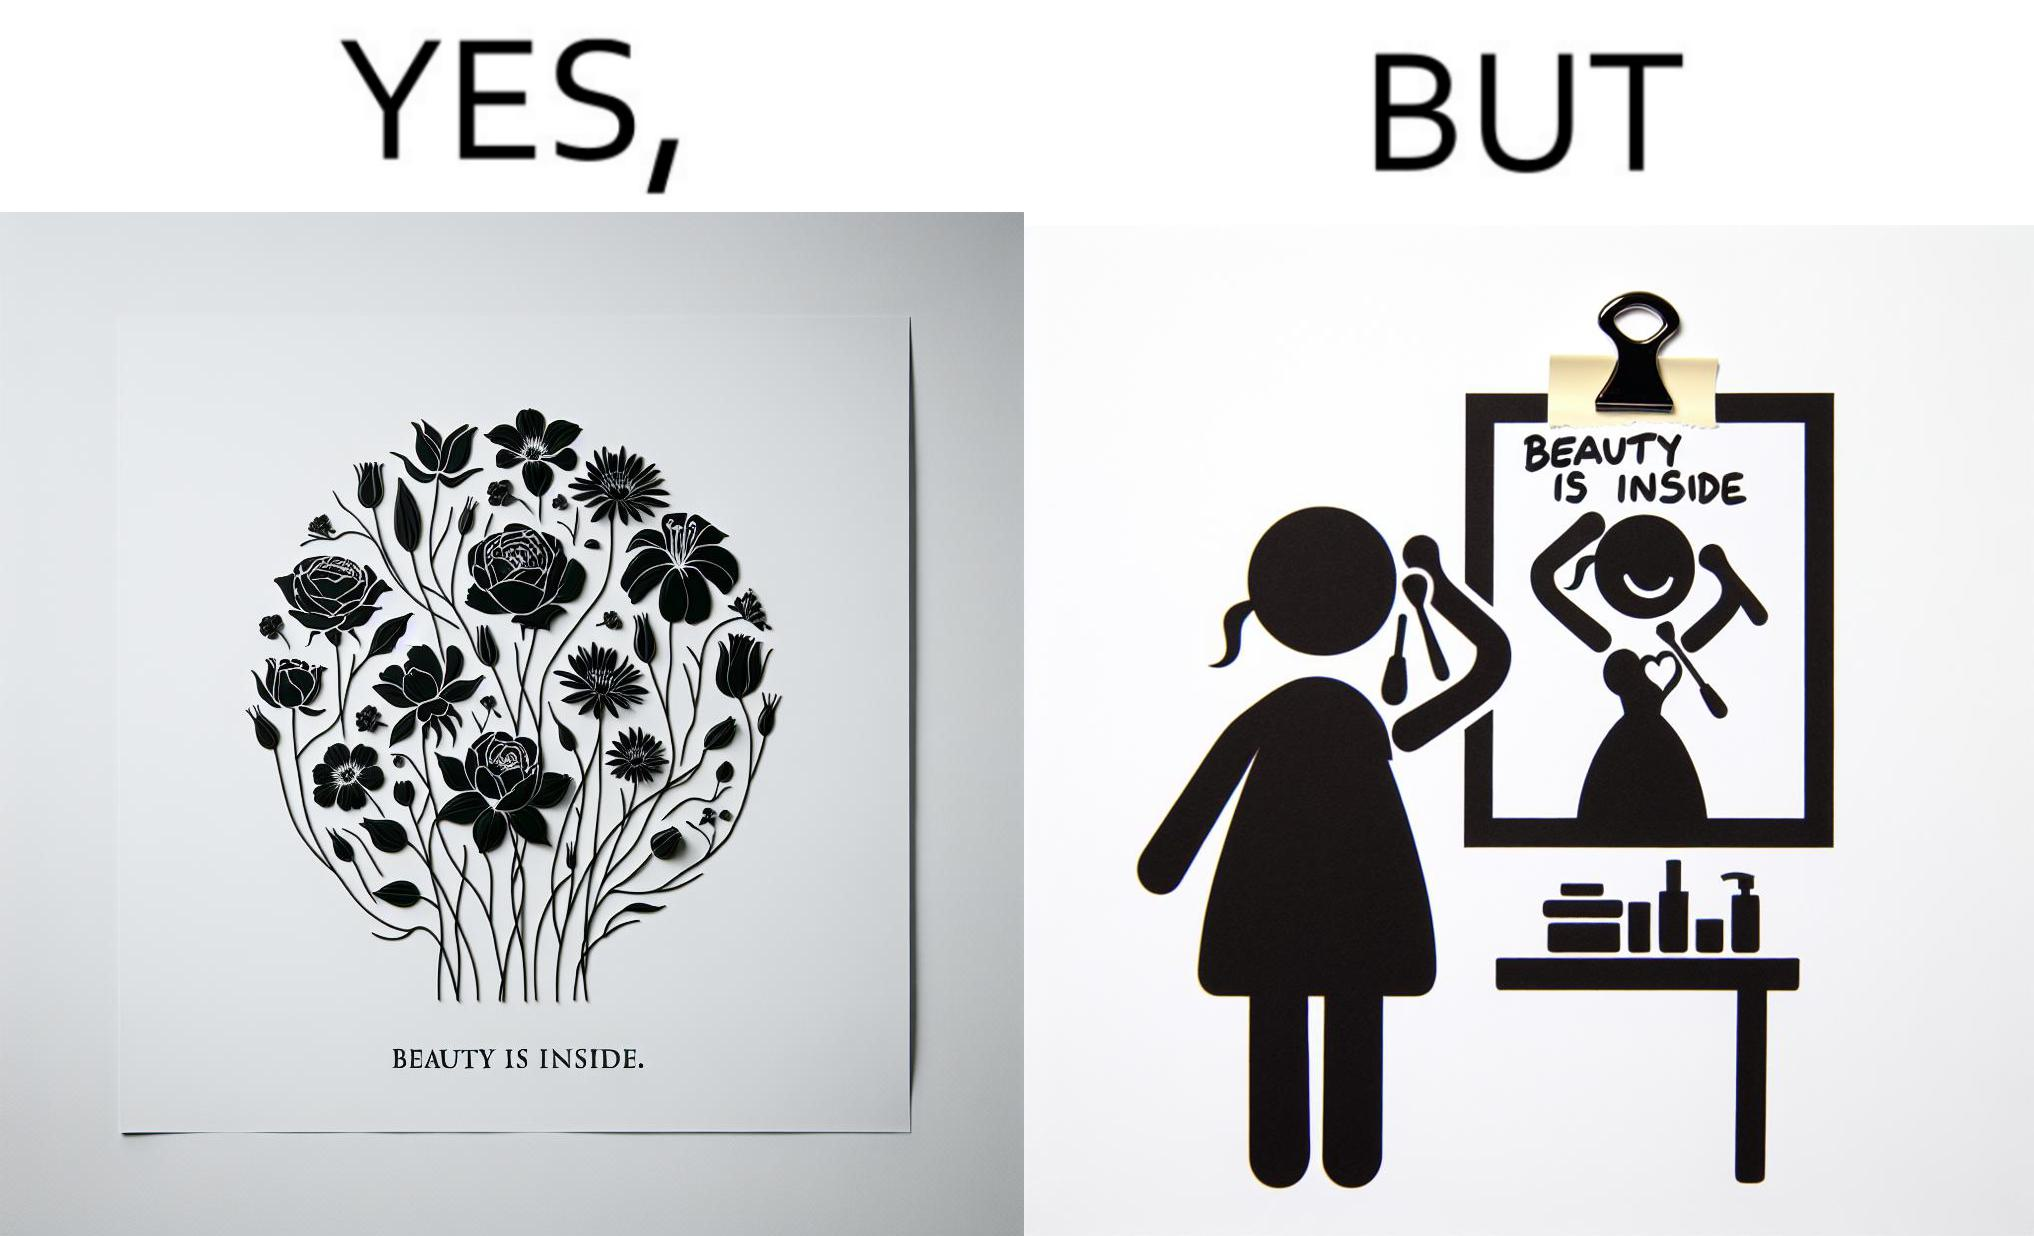Provide a description of this image. The image is satirical because while the text on the paper says that beauty lies inside, the woman ignores the note and continues to apply makeup to improve her outer beauty. 